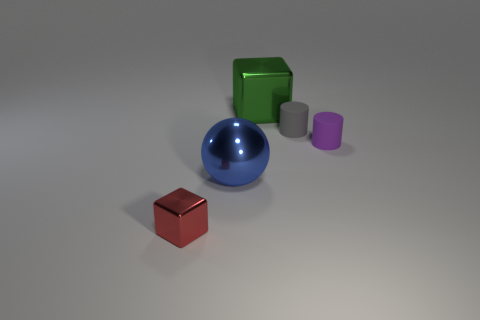Is there any other thing that has the same material as the large green cube?
Provide a succinct answer. Yes. There is a large object right of the big metallic object on the left side of the cube behind the small red metal cube; what is its shape?
Offer a very short reply. Cube. What number of other objects are there of the same shape as the blue object?
Provide a succinct answer. 0. There is a block that is the same size as the shiny ball; what color is it?
Ensure brevity in your answer.  Green. How many cylinders are matte objects or large green metal objects?
Your answer should be very brief. 2. How many blue cylinders are there?
Ensure brevity in your answer.  0. Does the green thing have the same shape as the shiny object on the left side of the large blue metal ball?
Provide a short and direct response. Yes. How many objects are either gray matte things or green metallic spheres?
Ensure brevity in your answer.  1. There is a large shiny thing behind the small rubber cylinder on the right side of the gray rubber thing; what shape is it?
Provide a succinct answer. Cube. Do the metal object that is in front of the big blue shiny thing and the large blue thing have the same shape?
Give a very brief answer. No. 